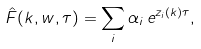<formula> <loc_0><loc_0><loc_500><loc_500>\hat { F } ( k , w , \tau ) = \sum _ { i } \alpha _ { i } \, e ^ { z _ { i } ( k ) \tau } ,</formula> 